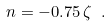Convert formula to latex. <formula><loc_0><loc_0><loc_500><loc_500>n = - 0 . 7 5 \, \zeta \ .</formula> 